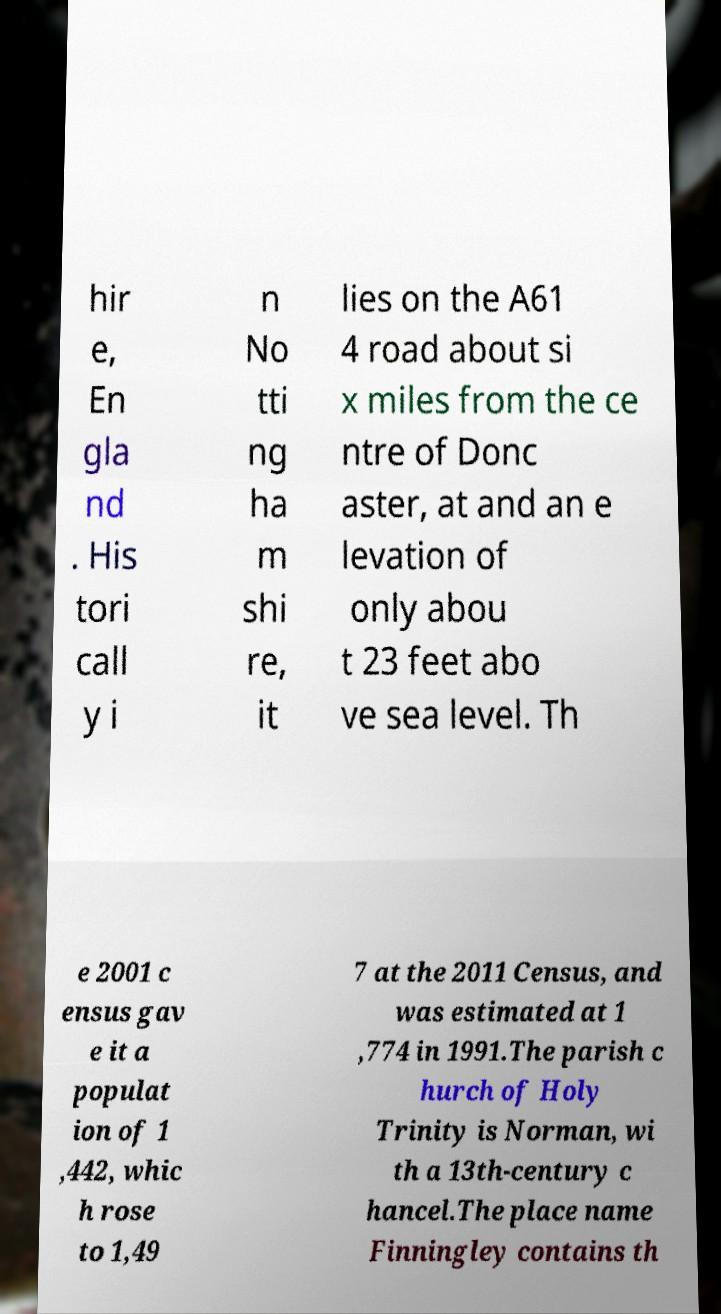Please identify and transcribe the text found in this image. hir e, En gla nd . His tori call y i n No tti ng ha m shi re, it lies on the A61 4 road about si x miles from the ce ntre of Donc aster, at and an e levation of only abou t 23 feet abo ve sea level. Th e 2001 c ensus gav e it a populat ion of 1 ,442, whic h rose to 1,49 7 at the 2011 Census, and was estimated at 1 ,774 in 1991.The parish c hurch of Holy Trinity is Norman, wi th a 13th-century c hancel.The place name Finningley contains th 